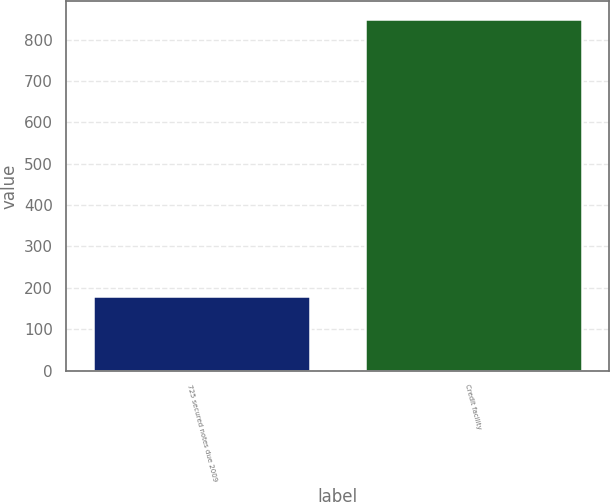Convert chart. <chart><loc_0><loc_0><loc_500><loc_500><bar_chart><fcel>725 secured notes due 2009<fcel>Credit facility<nl><fcel>180<fcel>850<nl></chart> 